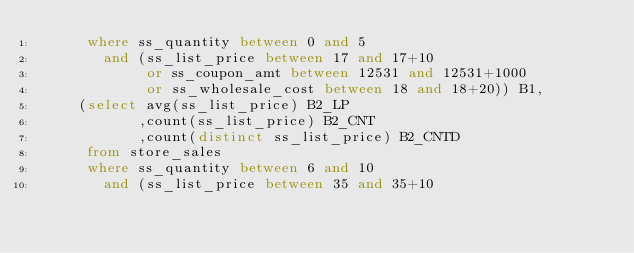Convert code to text. <code><loc_0><loc_0><loc_500><loc_500><_SQL_>      where ss_quantity between 0 and 5
        and (ss_list_price between 17 and 17+10 
             or ss_coupon_amt between 12531 and 12531+1000
             or ss_wholesale_cost between 18 and 18+20)) B1,
     (select avg(ss_list_price) B2_LP
            ,count(ss_list_price) B2_CNT
            ,count(distinct ss_list_price) B2_CNTD
      from store_sales
      where ss_quantity between 6 and 10
        and (ss_list_price between 35 and 35+10</code> 